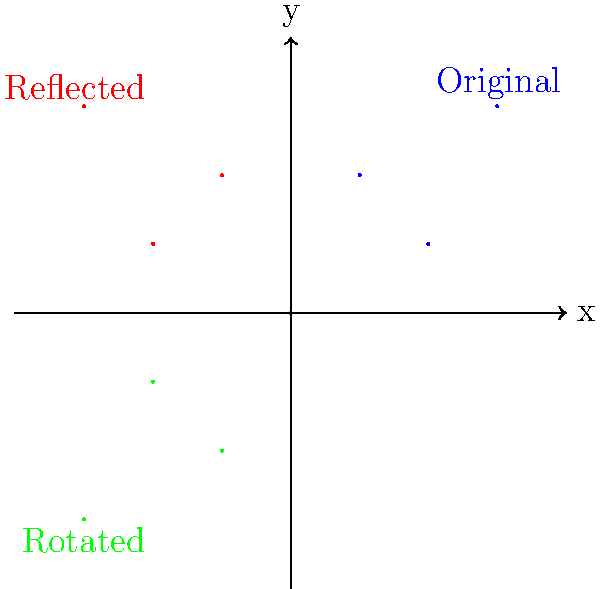As a talented illustrator creating surreal artwork, you're designing a kaleidoscopic pattern based on coordinate transformations. Given the original set of coordinates $A(0,0)$, $B(1,2)$, $C(2,1)$, and $D(3,3)$, you apply two transformations:
1. Reflect the original shape across the y-axis.
2. Rotate the original shape 180° around the origin.

What is the coordinate of point D after the rotation transformation? To solve this problem, let's follow these steps:

1. Identify the original coordinates:
   $A(0,0)$, $B(1,2)$, $C(2,1)$, $D(3,3)$

2. For the reflection across the y-axis:
   - The x-coordinate changes sign
   - The y-coordinate remains the same
   However, we don't need this for the final answer.

3. For the 180° rotation around the origin:
   - Both x and y coordinates change signs
   - This is equivalent to multiplying both coordinates by -1

4. Apply the rotation to point D(3,3):
   - New x-coordinate: $-3$
   - New y-coordinate: $-3$

Therefore, the coordinate of point D after the rotation transformation is $(-3,-3)$.
Answer: $(-3,-3)$ 